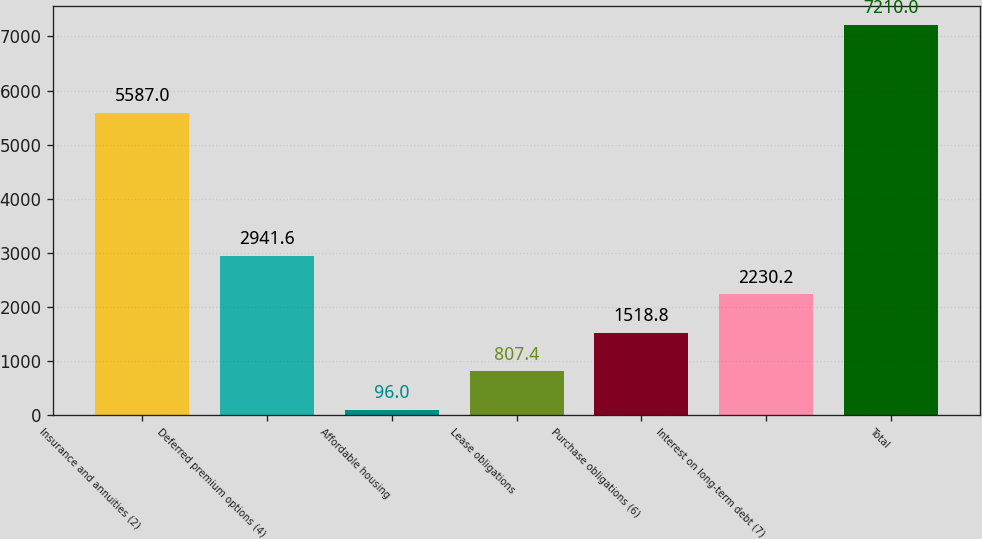Convert chart. <chart><loc_0><loc_0><loc_500><loc_500><bar_chart><fcel>Insurance and annuities (2)<fcel>Deferred premium options (4)<fcel>Affordable housing<fcel>Lease obligations<fcel>Purchase obligations (6)<fcel>Interest on long-term debt (7)<fcel>Total<nl><fcel>5587<fcel>2941.6<fcel>96<fcel>807.4<fcel>1518.8<fcel>2230.2<fcel>7210<nl></chart> 